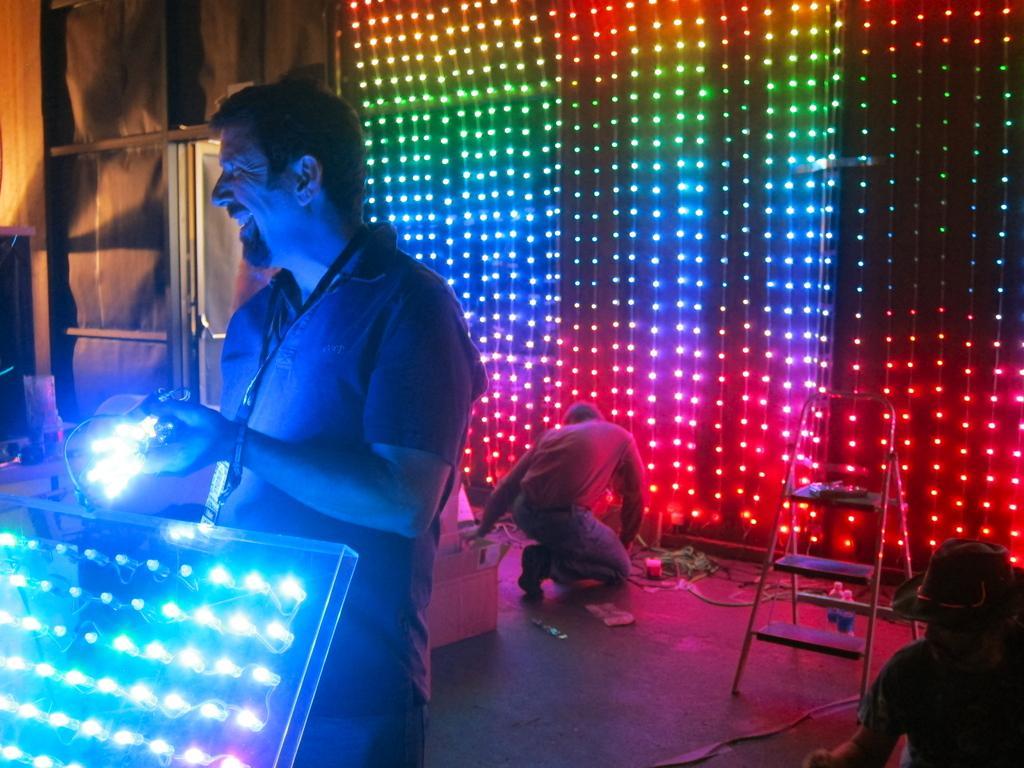How would you summarize this image in a sentence or two? At the left corner there is person standing and holding lights in his hand. In front of him there are lights on the boards. Behind him to the wall there are lights in different colors. Also on the floor there is a ladder and a man is sitting. At the right bottom of the image there is a person with a hat. 